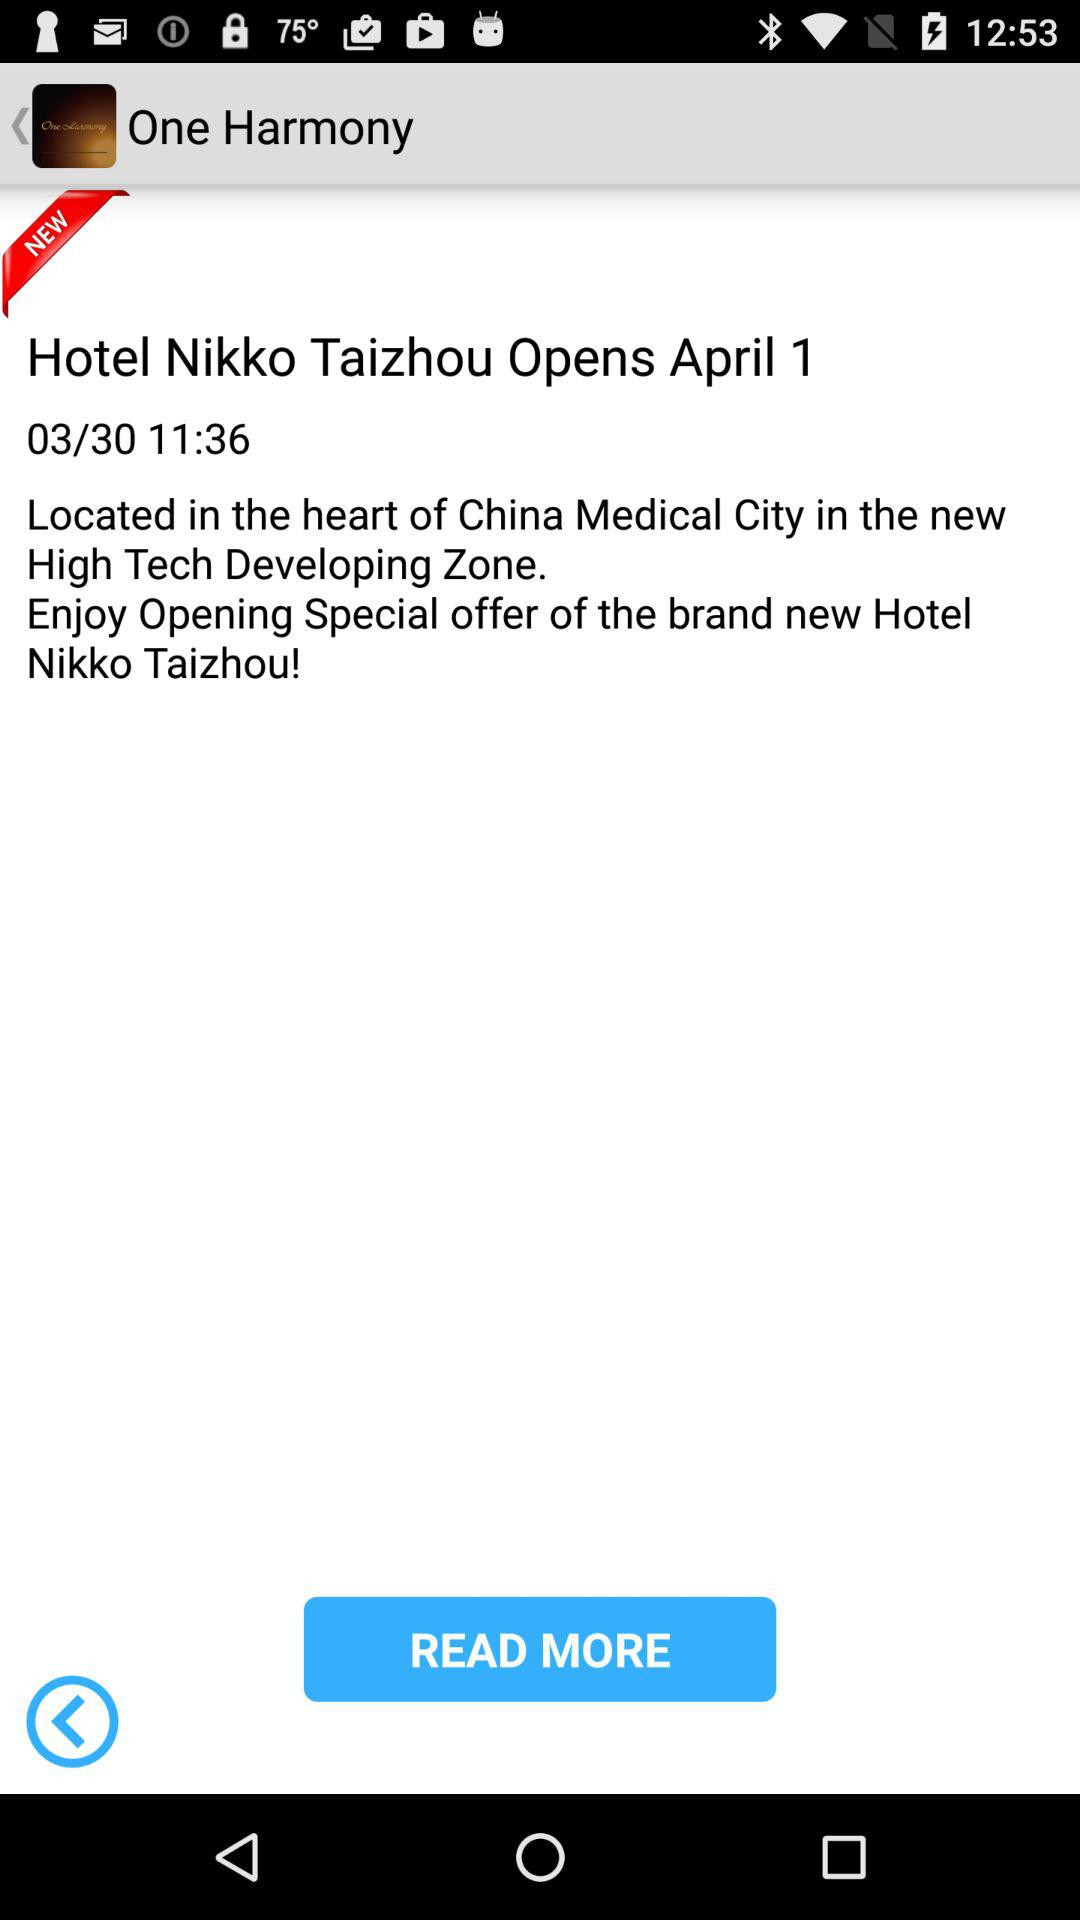What is the shown date? The shown dates are April 1 and March 30. 